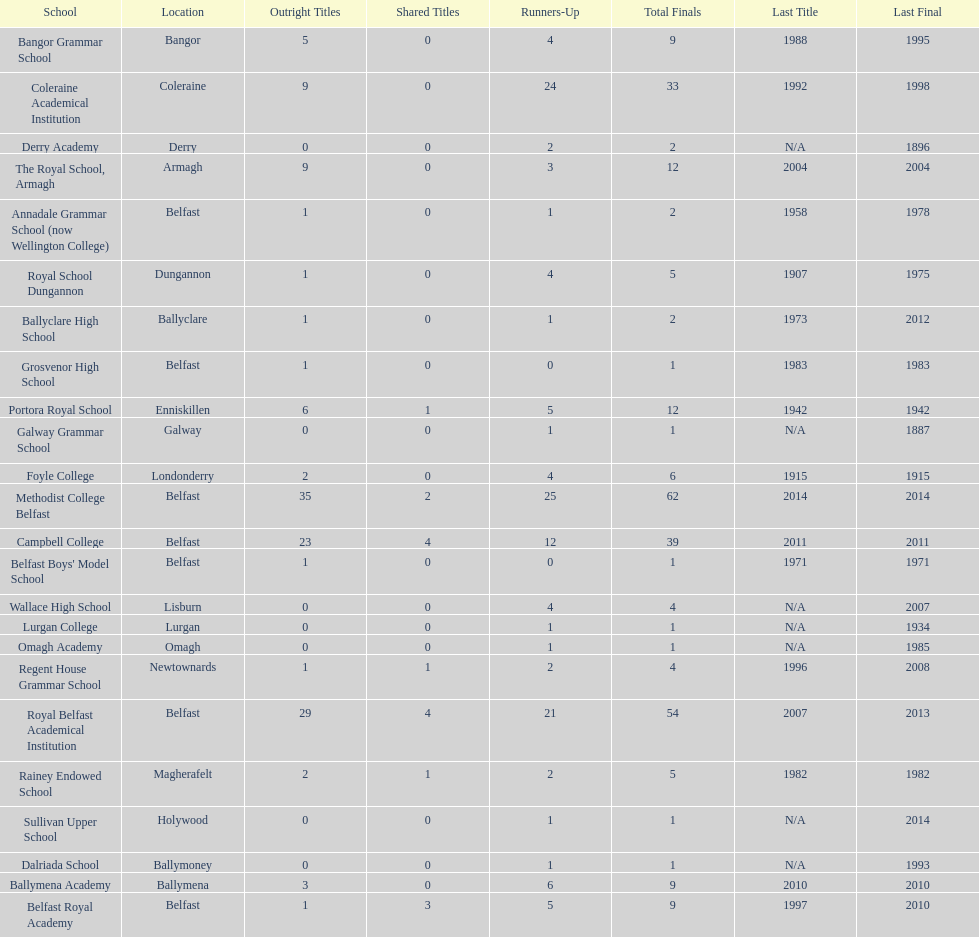How many schools have had at least 3 share titles? 3. 